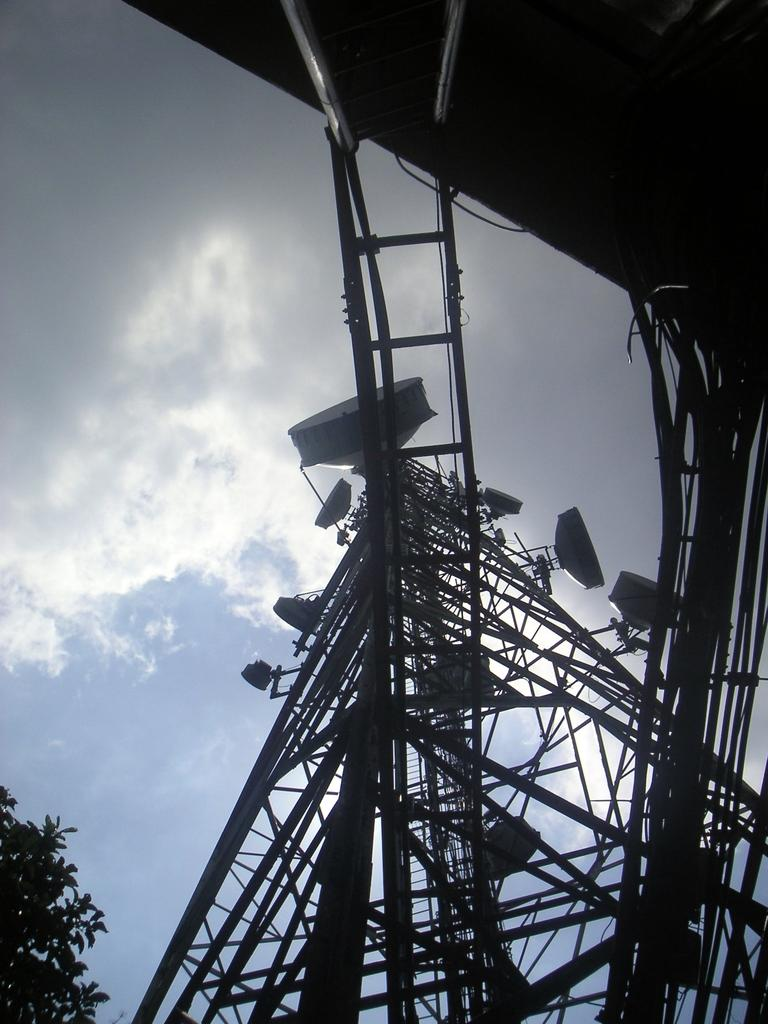What type of structure is in the image? There is an electric tower in the image. What is attached to the electric tower? There are antennas in the image. What type of natural elements are in the image? There are trees in the image. What is visible in the background of the image? The sky is visible in the image, and clouds are present in the sky. What type of stove can be seen in the image? There is no stove present in the image. What need is being fulfilled by the presence of the electric tower in the image? The image does not provide information about the purpose or need for the electric tower. 